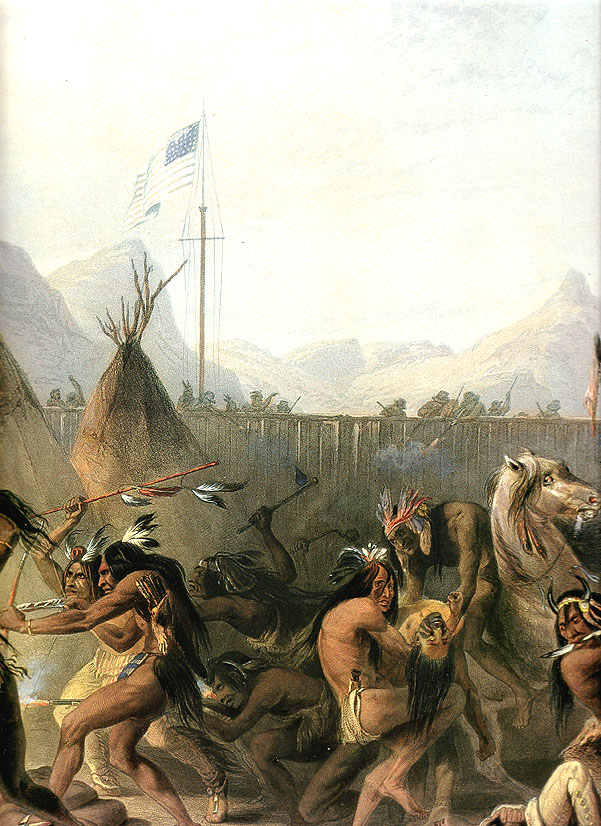What might be the emotions and stories behind this dancing scene? The emotions captured in this dancing scene are likely a blend of joy, unity, and cultural pride. The dancers, immersed in their movements, appear to be celebrating or honoring an important event or tradition. The stories behind such scenes often involve historical tales, spiritual beliefs, or communal values passed down through generations. Each movement, attire, and even the arrangement of the dancers can tell a story - perhaps of battles won, blessings received, or ancestors revered. This dance can be seen as a living tapestry where the rich history and heartfelt emotions of the community are dynamically expressed. Imagine if this painting could come to life. What would happen? If this painting could come to life, you'd be transported to a vibrant scene filled with the sound of drums and chants echoing through the air. The rhythmic beats would synchronize with the dancers' swift and deliberate movements, their traditional attire rustling with each step. The scent of smoke from nearby fires would mix with the crisp mountain air, enveloping the space in an authentic sensory experience. You might see children mimicking the dancers, elders recounting tales of old times, and a palpable sense of unity and pride filling the atmosphere. This immersive spectacle would offer a profound insight into the cultural richness and communal spirit of the depicted Native American tribe. What might have led to this moment captured in the painting? This moment might have been preceded by a significant event, such as a successful hunt, a peace treaty, a seasonal celebration, or a spiritual ceremony. The gathering of the tribe members for a dance indicates a special occasion that calls for communal participation and celebration. Preparations for the dance likely involved making costumes, rehearsing steps, and setting up the ceremonial grounds. Such moments are deeply rooted in cultural traditions, providing a space for community bonding, the passing of knowledge, and the honoring of ancestors. If you could ask the artist one question about this painting, what would it be? If given the chance, I would ask the artist: 'What was your inspiration and intended message behind including the American flag prominently in the midst of this traditional Native American dance scene?' Understanding the artist's intent could reveal deeper insights into the juxtaposition of elements and the historical or cultural commentary being made through the artwork. 